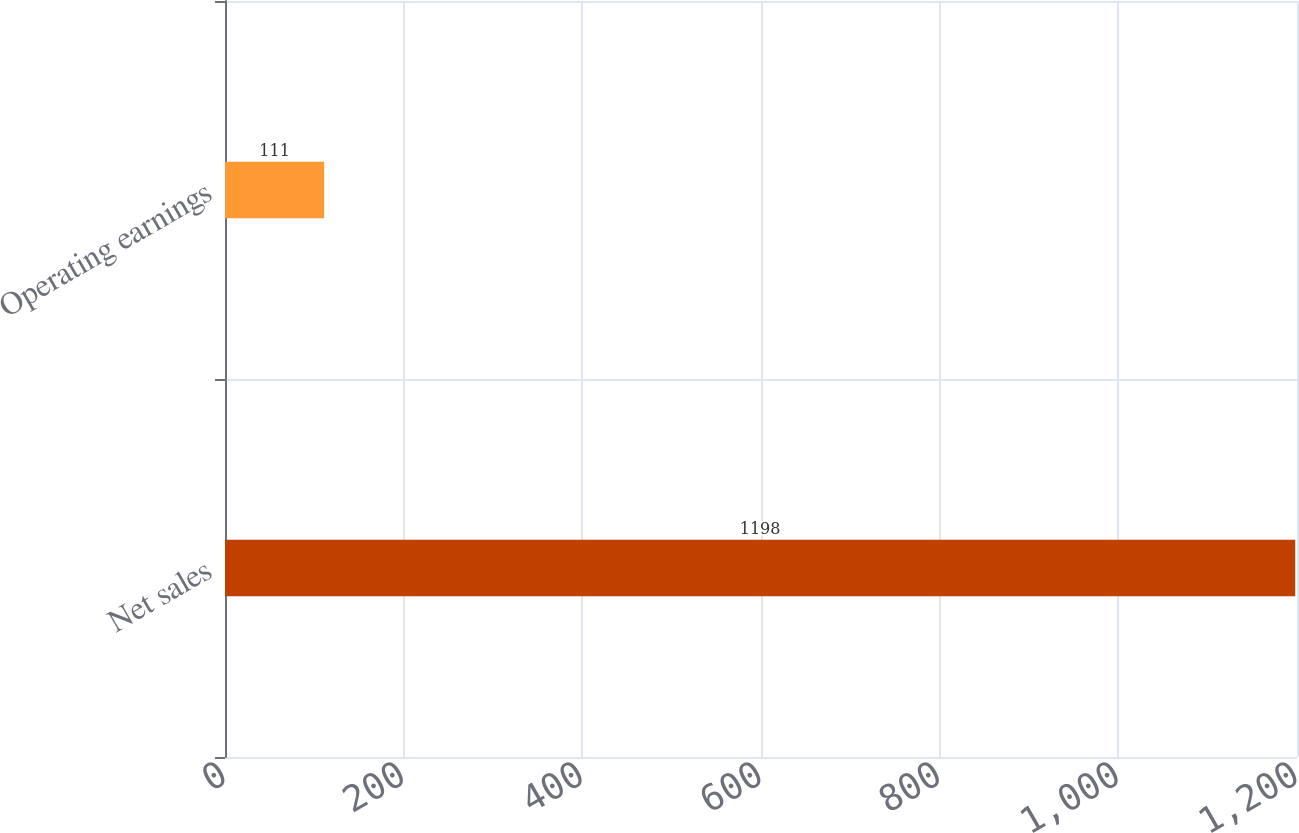<chart> <loc_0><loc_0><loc_500><loc_500><bar_chart><fcel>Net sales<fcel>Operating earnings<nl><fcel>1198<fcel>111<nl></chart> 